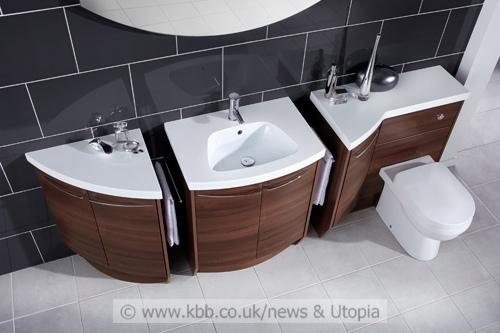In a concise manner, talk about the style and theme of the image. The bathroom has a contemporary design with white fixtures, dark wood cabinets, and black wall tiles. List three different materials and three different colors found in the image. Materials: ceramic, wood, metal. Colors: white, brown, black. Describe the image as if you were sharing it with someone who cannot see it. Imagine a modern bathroom with white sinks, a toilet, dark wood cabinets, black tiles on the wall, white tiles on the floor, and some accessories like a vase and toothbrush holder. Using simple words, mention the main objects found in the image. There are white sinks, a white toilet, brown cabinets, a translucent vase, black wall tiles, and white floor tiles. Write a sentence that gives an overall description of the image. The image shows a modern bathroom with white fixtures, dark wood cabinets, and shiny black wall tiles. Describe the locations of a few of the objects in relation to each other. The white toilet is near the brown cabinets and the white sinks are above the cabinets, with silver faucets. Mention the main colors of the objects in the image. The image has white sinks, a white toilet, silver fixtures, brown cabinets, and black wall tiles. Describe some of the unique features in the image. The image includes a long translucent vase, a freestanding chrome toothbrush holder, and a three-piece bathroom cabinet. Explain the overall vibe or atmosphere of the image in one sentence. The image portrays a clean, modern, and stylish bathroom with a well-coordinated color scheme. Write a description of the image focusing on the textures and materials. The image features shiny black wall tiles, white ceramic sinks and toilet, dark wood cabinets with chrome handles, and white floor tiles. 